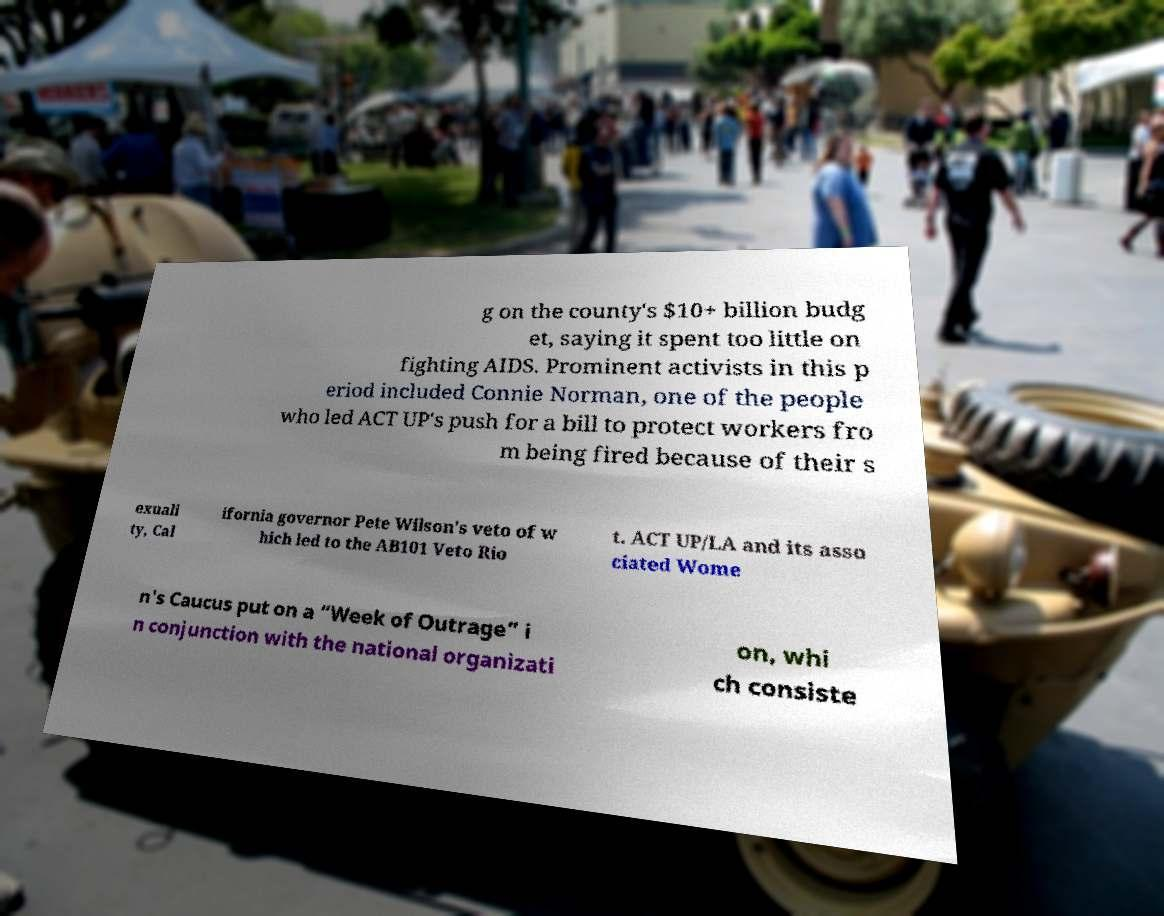I need the written content from this picture converted into text. Can you do that? g on the county's $10+ billion budg et, saying it spent too little on fighting AIDS. Prominent activists in this p eriod included Connie Norman, one of the people who led ACT UP's push for a bill to protect workers fro m being fired because of their s exuali ty, Cal ifornia governor Pete Wilson's veto of w hich led to the AB101 Veto Rio t. ACT UP/LA and its asso ciated Wome n's Caucus put on a “Week of Outrage” i n conjunction with the national organizati on, whi ch consiste 